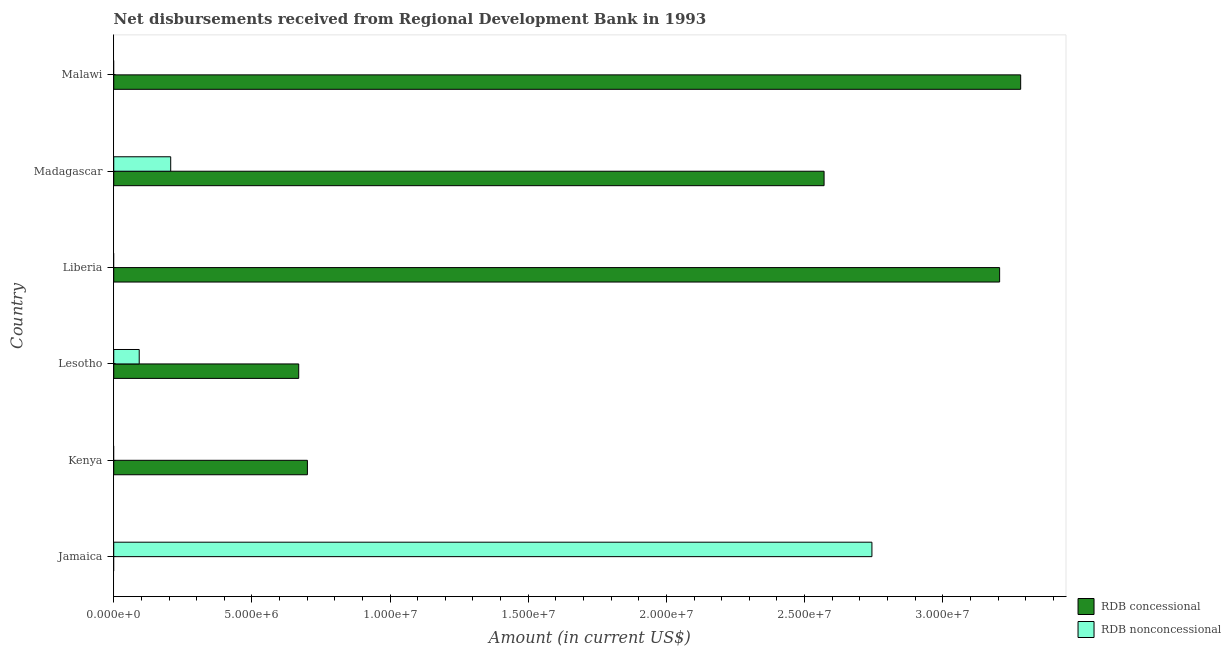How many different coloured bars are there?
Your response must be concise. 2. Are the number of bars on each tick of the Y-axis equal?
Your answer should be very brief. No. What is the label of the 6th group of bars from the top?
Give a very brief answer. Jamaica. What is the net non concessional disbursements from rdb in Lesotho?
Make the answer very short. 9.22e+05. Across all countries, what is the maximum net non concessional disbursements from rdb?
Provide a succinct answer. 2.74e+07. Across all countries, what is the minimum net non concessional disbursements from rdb?
Your answer should be very brief. 0. In which country was the net concessional disbursements from rdb maximum?
Your response must be concise. Malawi. What is the total net non concessional disbursements from rdb in the graph?
Provide a succinct answer. 3.04e+07. What is the difference between the net non concessional disbursements from rdb in Lesotho and that in Madagascar?
Your answer should be very brief. -1.14e+06. What is the difference between the net concessional disbursements from rdb in Madagascar and the net non concessional disbursements from rdb in Liberia?
Offer a very short reply. 2.57e+07. What is the average net concessional disbursements from rdb per country?
Offer a terse response. 1.74e+07. What is the difference between the net concessional disbursements from rdb and net non concessional disbursements from rdb in Madagascar?
Keep it short and to the point. 2.36e+07. What is the ratio of the net concessional disbursements from rdb in Lesotho to that in Madagascar?
Offer a terse response. 0.26. Is the net concessional disbursements from rdb in Kenya less than that in Lesotho?
Your response must be concise. No. What is the difference between the highest and the second highest net non concessional disbursements from rdb?
Your answer should be compact. 2.54e+07. What is the difference between the highest and the lowest net concessional disbursements from rdb?
Your answer should be very brief. 3.28e+07. How many bars are there?
Offer a terse response. 8. What is the difference between two consecutive major ticks on the X-axis?
Offer a terse response. 5.00e+06. Are the values on the major ticks of X-axis written in scientific E-notation?
Provide a short and direct response. Yes. Does the graph contain any zero values?
Provide a short and direct response. Yes. How many legend labels are there?
Your response must be concise. 2. What is the title of the graph?
Offer a terse response. Net disbursements received from Regional Development Bank in 1993. What is the Amount (in current US$) of RDB nonconcessional in Jamaica?
Offer a terse response. 2.74e+07. What is the Amount (in current US$) in RDB concessional in Kenya?
Make the answer very short. 7.01e+06. What is the Amount (in current US$) in RDB nonconcessional in Kenya?
Your answer should be very brief. 0. What is the Amount (in current US$) of RDB concessional in Lesotho?
Make the answer very short. 6.69e+06. What is the Amount (in current US$) of RDB nonconcessional in Lesotho?
Make the answer very short. 9.22e+05. What is the Amount (in current US$) in RDB concessional in Liberia?
Offer a terse response. 3.21e+07. What is the Amount (in current US$) of RDB concessional in Madagascar?
Your response must be concise. 2.57e+07. What is the Amount (in current US$) of RDB nonconcessional in Madagascar?
Your answer should be very brief. 2.06e+06. What is the Amount (in current US$) of RDB concessional in Malawi?
Your answer should be compact. 3.28e+07. What is the Amount (in current US$) in RDB nonconcessional in Malawi?
Your answer should be very brief. 0. Across all countries, what is the maximum Amount (in current US$) in RDB concessional?
Give a very brief answer. 3.28e+07. Across all countries, what is the maximum Amount (in current US$) of RDB nonconcessional?
Provide a succinct answer. 2.74e+07. Across all countries, what is the minimum Amount (in current US$) of RDB concessional?
Ensure brevity in your answer.  0. Across all countries, what is the minimum Amount (in current US$) of RDB nonconcessional?
Your answer should be very brief. 0. What is the total Amount (in current US$) of RDB concessional in the graph?
Provide a succinct answer. 1.04e+08. What is the total Amount (in current US$) in RDB nonconcessional in the graph?
Make the answer very short. 3.04e+07. What is the difference between the Amount (in current US$) in RDB nonconcessional in Jamaica and that in Lesotho?
Give a very brief answer. 2.65e+07. What is the difference between the Amount (in current US$) of RDB nonconcessional in Jamaica and that in Madagascar?
Your answer should be compact. 2.54e+07. What is the difference between the Amount (in current US$) in RDB concessional in Kenya and that in Lesotho?
Your response must be concise. 3.14e+05. What is the difference between the Amount (in current US$) of RDB concessional in Kenya and that in Liberia?
Provide a succinct answer. -2.50e+07. What is the difference between the Amount (in current US$) of RDB concessional in Kenya and that in Madagascar?
Provide a short and direct response. -1.87e+07. What is the difference between the Amount (in current US$) in RDB concessional in Kenya and that in Malawi?
Provide a succinct answer. -2.58e+07. What is the difference between the Amount (in current US$) in RDB concessional in Lesotho and that in Liberia?
Ensure brevity in your answer.  -2.54e+07. What is the difference between the Amount (in current US$) in RDB concessional in Lesotho and that in Madagascar?
Give a very brief answer. -1.90e+07. What is the difference between the Amount (in current US$) of RDB nonconcessional in Lesotho and that in Madagascar?
Keep it short and to the point. -1.14e+06. What is the difference between the Amount (in current US$) of RDB concessional in Lesotho and that in Malawi?
Keep it short and to the point. -2.61e+07. What is the difference between the Amount (in current US$) in RDB concessional in Liberia and that in Madagascar?
Provide a short and direct response. 6.35e+06. What is the difference between the Amount (in current US$) in RDB concessional in Liberia and that in Malawi?
Your answer should be compact. -7.62e+05. What is the difference between the Amount (in current US$) in RDB concessional in Madagascar and that in Malawi?
Give a very brief answer. -7.11e+06. What is the difference between the Amount (in current US$) of RDB concessional in Kenya and the Amount (in current US$) of RDB nonconcessional in Lesotho?
Your answer should be very brief. 6.09e+06. What is the difference between the Amount (in current US$) of RDB concessional in Kenya and the Amount (in current US$) of RDB nonconcessional in Madagascar?
Your answer should be compact. 4.95e+06. What is the difference between the Amount (in current US$) in RDB concessional in Lesotho and the Amount (in current US$) in RDB nonconcessional in Madagascar?
Give a very brief answer. 4.63e+06. What is the difference between the Amount (in current US$) of RDB concessional in Liberia and the Amount (in current US$) of RDB nonconcessional in Madagascar?
Ensure brevity in your answer.  3.00e+07. What is the average Amount (in current US$) in RDB concessional per country?
Make the answer very short. 1.74e+07. What is the average Amount (in current US$) in RDB nonconcessional per country?
Ensure brevity in your answer.  5.07e+06. What is the difference between the Amount (in current US$) in RDB concessional and Amount (in current US$) in RDB nonconcessional in Lesotho?
Keep it short and to the point. 5.77e+06. What is the difference between the Amount (in current US$) in RDB concessional and Amount (in current US$) in RDB nonconcessional in Madagascar?
Give a very brief answer. 2.36e+07. What is the ratio of the Amount (in current US$) of RDB nonconcessional in Jamaica to that in Lesotho?
Your response must be concise. 29.76. What is the ratio of the Amount (in current US$) in RDB nonconcessional in Jamaica to that in Madagascar?
Keep it short and to the point. 13.31. What is the ratio of the Amount (in current US$) of RDB concessional in Kenya to that in Lesotho?
Your answer should be very brief. 1.05. What is the ratio of the Amount (in current US$) in RDB concessional in Kenya to that in Liberia?
Ensure brevity in your answer.  0.22. What is the ratio of the Amount (in current US$) in RDB concessional in Kenya to that in Madagascar?
Provide a short and direct response. 0.27. What is the ratio of the Amount (in current US$) of RDB concessional in Kenya to that in Malawi?
Keep it short and to the point. 0.21. What is the ratio of the Amount (in current US$) in RDB concessional in Lesotho to that in Liberia?
Offer a very short reply. 0.21. What is the ratio of the Amount (in current US$) of RDB concessional in Lesotho to that in Madagascar?
Give a very brief answer. 0.26. What is the ratio of the Amount (in current US$) of RDB nonconcessional in Lesotho to that in Madagascar?
Ensure brevity in your answer.  0.45. What is the ratio of the Amount (in current US$) of RDB concessional in Lesotho to that in Malawi?
Your response must be concise. 0.2. What is the ratio of the Amount (in current US$) in RDB concessional in Liberia to that in Madagascar?
Your response must be concise. 1.25. What is the ratio of the Amount (in current US$) in RDB concessional in Liberia to that in Malawi?
Keep it short and to the point. 0.98. What is the ratio of the Amount (in current US$) of RDB concessional in Madagascar to that in Malawi?
Keep it short and to the point. 0.78. What is the difference between the highest and the second highest Amount (in current US$) of RDB concessional?
Make the answer very short. 7.62e+05. What is the difference between the highest and the second highest Amount (in current US$) in RDB nonconcessional?
Your answer should be very brief. 2.54e+07. What is the difference between the highest and the lowest Amount (in current US$) of RDB concessional?
Ensure brevity in your answer.  3.28e+07. What is the difference between the highest and the lowest Amount (in current US$) in RDB nonconcessional?
Ensure brevity in your answer.  2.74e+07. 